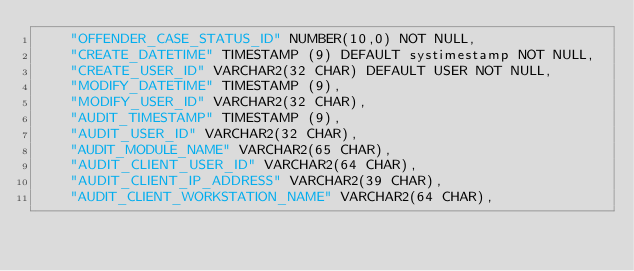Convert code to text. <code><loc_0><loc_0><loc_500><loc_500><_SQL_>    "OFFENDER_CASE_STATUS_ID" NUMBER(10,0) NOT NULL,
    "CREATE_DATETIME" TIMESTAMP (9) DEFAULT systimestamp NOT NULL,
    "CREATE_USER_ID" VARCHAR2(32 CHAR) DEFAULT USER NOT NULL,
    "MODIFY_DATETIME" TIMESTAMP (9),
    "MODIFY_USER_ID" VARCHAR2(32 CHAR),
    "AUDIT_TIMESTAMP" TIMESTAMP (9),
    "AUDIT_USER_ID" VARCHAR2(32 CHAR),
    "AUDIT_MODULE_NAME" VARCHAR2(65 CHAR),
    "AUDIT_CLIENT_USER_ID" VARCHAR2(64 CHAR),
    "AUDIT_CLIENT_IP_ADDRESS" VARCHAR2(39 CHAR),
    "AUDIT_CLIENT_WORKSTATION_NAME" VARCHAR2(64 CHAR),</code> 